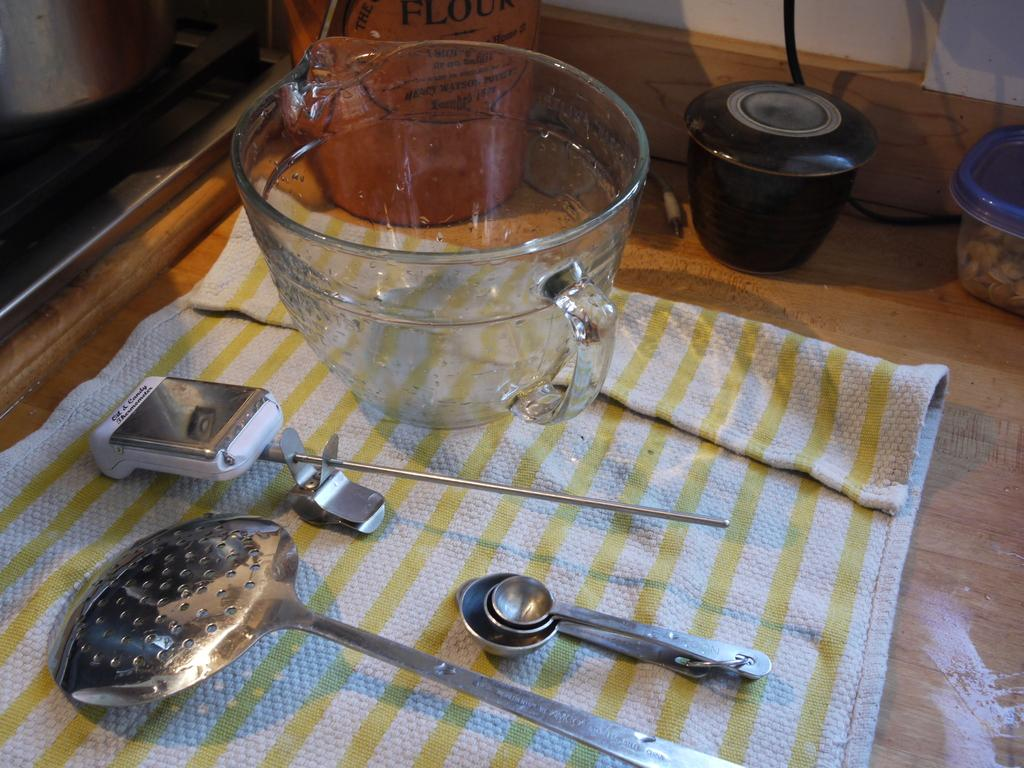What utensils can be seen in the image? There are spoons in the image. What type of container is visible in the image? There is a glass bowl in the image. What might be used for cleaning or wiping in the image? Napkins are present in the image. What is the surface made of that the objects are placed on? The objects are placed on a wooden surface. What type of cork can be seen in the image? There is no cork present in the image. How does the air affect the objects in the image? The air does not affect the objects in the image; they are stationary on the wooden surface. 